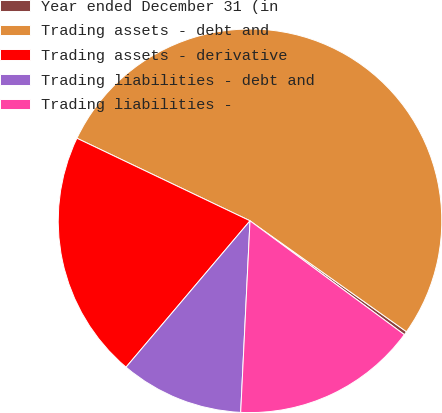Convert chart to OTSL. <chart><loc_0><loc_0><loc_500><loc_500><pie_chart><fcel>Year ended December 31 (in<fcel>Trading assets - debt and<fcel>Trading assets - derivative<fcel>Trading liabilities - debt and<fcel>Trading liabilities -<nl><fcel>0.3%<fcel>52.73%<fcel>20.9%<fcel>10.41%<fcel>15.66%<nl></chart> 